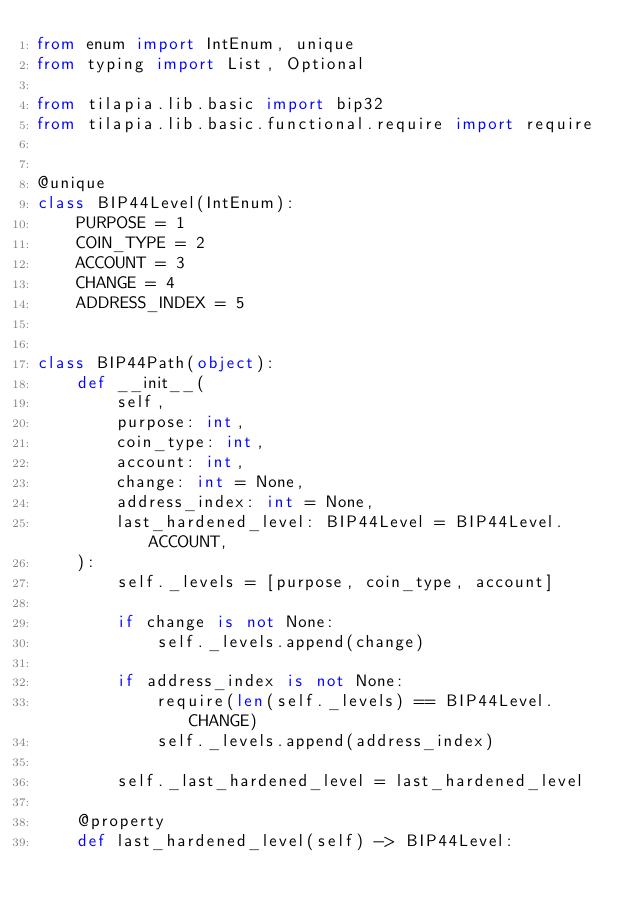<code> <loc_0><loc_0><loc_500><loc_500><_Python_>from enum import IntEnum, unique
from typing import List, Optional

from tilapia.lib.basic import bip32
from tilapia.lib.basic.functional.require import require


@unique
class BIP44Level(IntEnum):
    PURPOSE = 1
    COIN_TYPE = 2
    ACCOUNT = 3
    CHANGE = 4
    ADDRESS_INDEX = 5


class BIP44Path(object):
    def __init__(
        self,
        purpose: int,
        coin_type: int,
        account: int,
        change: int = None,
        address_index: int = None,
        last_hardened_level: BIP44Level = BIP44Level.ACCOUNT,
    ):
        self._levels = [purpose, coin_type, account]

        if change is not None:
            self._levels.append(change)

        if address_index is not None:
            require(len(self._levels) == BIP44Level.CHANGE)
            self._levels.append(address_index)

        self._last_hardened_level = last_hardened_level

    @property
    def last_hardened_level(self) -> BIP44Level:</code> 